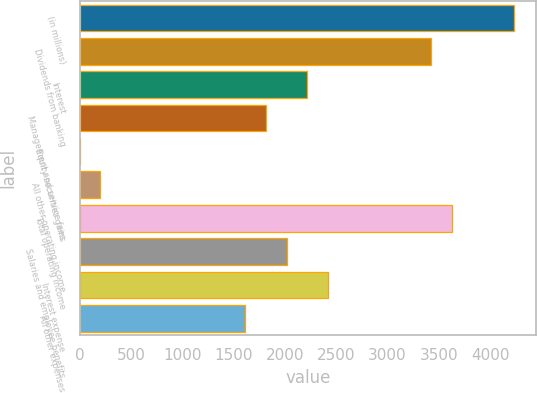Convert chart to OTSL. <chart><loc_0><loc_0><loc_500><loc_500><bar_chart><fcel>(in millions)<fcel>Dividends from banking<fcel>Interest<fcel>Management and service fees<fcel>Equity securities gains<fcel>All other operating income<fcel>Total operating income<fcel>Salaries and employee benefits<fcel>Interest expense<fcel>All other expenses<nl><fcel>4234.6<fcel>3428.2<fcel>2218.6<fcel>1815.4<fcel>1<fcel>202.6<fcel>3629.8<fcel>2017<fcel>2420.2<fcel>1613.8<nl></chart> 